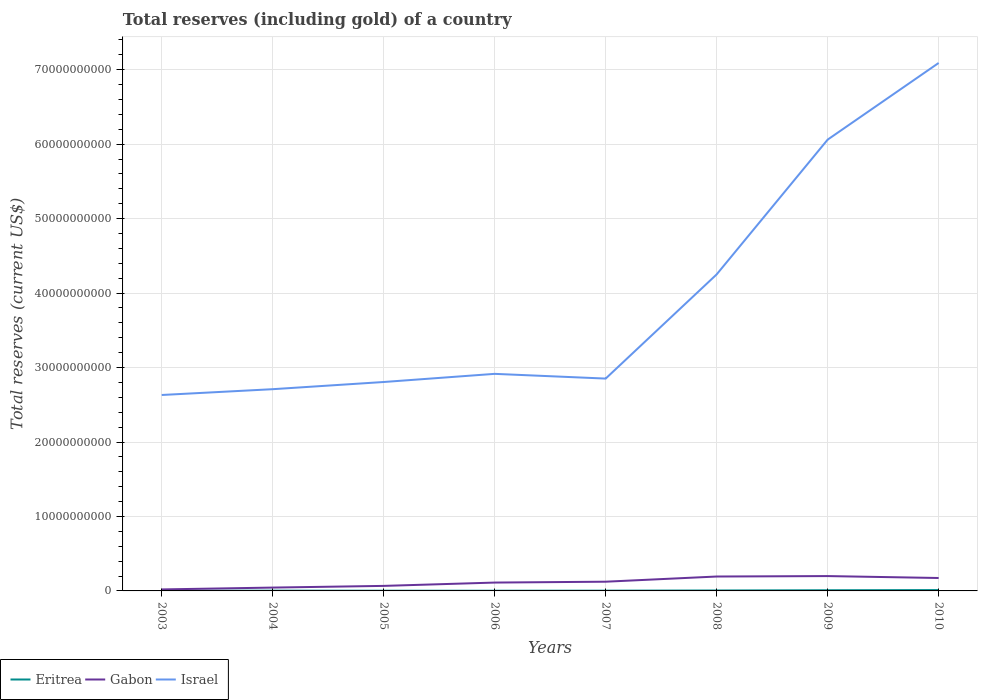How many different coloured lines are there?
Ensure brevity in your answer.  3. Is the number of lines equal to the number of legend labels?
Give a very brief answer. Yes. Across all years, what is the maximum total reserves (including gold) in Israel?
Give a very brief answer. 2.63e+1. In which year was the total reserves (including gold) in Eritrea maximum?
Offer a very short reply. 2003. What is the total total reserves (including gold) in Israel in the graph?
Your response must be concise. -3.15e+1. What is the difference between the highest and the second highest total reserves (including gold) in Israel?
Your answer should be very brief. 4.46e+1. What is the difference between the highest and the lowest total reserves (including gold) in Eritrea?
Your answer should be very brief. 3. Is the total reserves (including gold) in Gabon strictly greater than the total reserves (including gold) in Israel over the years?
Offer a terse response. Yes. How many years are there in the graph?
Your answer should be very brief. 8. What is the difference between two consecutive major ticks on the Y-axis?
Your answer should be compact. 1.00e+1. How many legend labels are there?
Offer a very short reply. 3. What is the title of the graph?
Provide a short and direct response. Total reserves (including gold) of a country. Does "Latvia" appear as one of the legend labels in the graph?
Your answer should be compact. No. What is the label or title of the X-axis?
Your answer should be compact. Years. What is the label or title of the Y-axis?
Make the answer very short. Total reserves (current US$). What is the Total reserves (current US$) of Eritrea in 2003?
Give a very brief answer. 2.47e+07. What is the Total reserves (current US$) of Gabon in 2003?
Your answer should be very brief. 2.02e+08. What is the Total reserves (current US$) of Israel in 2003?
Your response must be concise. 2.63e+1. What is the Total reserves (current US$) of Eritrea in 2004?
Make the answer very short. 3.47e+07. What is the Total reserves (current US$) in Gabon in 2004?
Make the answer very short. 4.49e+08. What is the Total reserves (current US$) of Israel in 2004?
Make the answer very short. 2.71e+1. What is the Total reserves (current US$) in Eritrea in 2005?
Ensure brevity in your answer.  2.79e+07. What is the Total reserves (current US$) in Gabon in 2005?
Make the answer very short. 6.75e+08. What is the Total reserves (current US$) of Israel in 2005?
Give a very brief answer. 2.81e+1. What is the Total reserves (current US$) in Eritrea in 2006?
Offer a terse response. 2.54e+07. What is the Total reserves (current US$) in Gabon in 2006?
Offer a terse response. 1.12e+09. What is the Total reserves (current US$) of Israel in 2006?
Ensure brevity in your answer.  2.92e+1. What is the Total reserves (current US$) of Eritrea in 2007?
Your response must be concise. 3.43e+07. What is the Total reserves (current US$) in Gabon in 2007?
Ensure brevity in your answer.  1.24e+09. What is the Total reserves (current US$) of Israel in 2007?
Keep it short and to the point. 2.85e+1. What is the Total reserves (current US$) of Eritrea in 2008?
Ensure brevity in your answer.  5.79e+07. What is the Total reserves (current US$) in Gabon in 2008?
Your answer should be very brief. 1.93e+09. What is the Total reserves (current US$) of Israel in 2008?
Keep it short and to the point. 4.25e+1. What is the Total reserves (current US$) in Eritrea in 2009?
Offer a very short reply. 9.00e+07. What is the Total reserves (current US$) of Gabon in 2009?
Make the answer very short. 1.99e+09. What is the Total reserves (current US$) in Israel in 2009?
Your answer should be compact. 6.06e+1. What is the Total reserves (current US$) in Eritrea in 2010?
Give a very brief answer. 1.14e+08. What is the Total reserves (current US$) in Gabon in 2010?
Provide a succinct answer. 1.74e+09. What is the Total reserves (current US$) in Israel in 2010?
Your answer should be compact. 7.09e+1. Across all years, what is the maximum Total reserves (current US$) of Eritrea?
Keep it short and to the point. 1.14e+08. Across all years, what is the maximum Total reserves (current US$) in Gabon?
Your answer should be compact. 1.99e+09. Across all years, what is the maximum Total reserves (current US$) of Israel?
Give a very brief answer. 7.09e+1. Across all years, what is the minimum Total reserves (current US$) of Eritrea?
Your answer should be very brief. 2.47e+07. Across all years, what is the minimum Total reserves (current US$) in Gabon?
Provide a succinct answer. 2.02e+08. Across all years, what is the minimum Total reserves (current US$) in Israel?
Provide a succinct answer. 2.63e+1. What is the total Total reserves (current US$) in Eritrea in the graph?
Ensure brevity in your answer.  4.09e+08. What is the total Total reserves (current US$) of Gabon in the graph?
Your response must be concise. 9.35e+09. What is the total Total reserves (current US$) of Israel in the graph?
Your answer should be compact. 3.13e+11. What is the difference between the Total reserves (current US$) in Eritrea in 2003 and that in 2004?
Ensure brevity in your answer.  -1.00e+07. What is the difference between the Total reserves (current US$) of Gabon in 2003 and that in 2004?
Give a very brief answer. -2.47e+08. What is the difference between the Total reserves (current US$) in Israel in 2003 and that in 2004?
Provide a succinct answer. -7.79e+08. What is the difference between the Total reserves (current US$) in Eritrea in 2003 and that in 2005?
Your response must be concise. -3.24e+06. What is the difference between the Total reserves (current US$) in Gabon in 2003 and that in 2005?
Your response must be concise. -4.73e+08. What is the difference between the Total reserves (current US$) in Israel in 2003 and that in 2005?
Ensure brevity in your answer.  -1.74e+09. What is the difference between the Total reserves (current US$) of Eritrea in 2003 and that in 2006?
Make the answer very short. -6.47e+05. What is the difference between the Total reserves (current US$) in Gabon in 2003 and that in 2006?
Give a very brief answer. -9.20e+08. What is the difference between the Total reserves (current US$) in Israel in 2003 and that in 2006?
Ensure brevity in your answer.  -2.84e+09. What is the difference between the Total reserves (current US$) of Eritrea in 2003 and that in 2007?
Give a very brief answer. -9.58e+06. What is the difference between the Total reserves (current US$) of Gabon in 2003 and that in 2007?
Your answer should be compact. -1.04e+09. What is the difference between the Total reserves (current US$) in Israel in 2003 and that in 2007?
Make the answer very short. -2.20e+09. What is the difference between the Total reserves (current US$) in Eritrea in 2003 and that in 2008?
Offer a terse response. -3.32e+07. What is the difference between the Total reserves (current US$) in Gabon in 2003 and that in 2008?
Your answer should be very brief. -1.73e+09. What is the difference between the Total reserves (current US$) in Israel in 2003 and that in 2008?
Ensure brevity in your answer.  -1.62e+1. What is the difference between the Total reserves (current US$) in Eritrea in 2003 and that in 2009?
Provide a short and direct response. -6.53e+07. What is the difference between the Total reserves (current US$) of Gabon in 2003 and that in 2009?
Give a very brief answer. -1.79e+09. What is the difference between the Total reserves (current US$) of Israel in 2003 and that in 2009?
Your response must be concise. -3.43e+1. What is the difference between the Total reserves (current US$) of Eritrea in 2003 and that in 2010?
Provide a succinct answer. -8.94e+07. What is the difference between the Total reserves (current US$) of Gabon in 2003 and that in 2010?
Your response must be concise. -1.53e+09. What is the difference between the Total reserves (current US$) in Israel in 2003 and that in 2010?
Your answer should be compact. -4.46e+1. What is the difference between the Total reserves (current US$) in Eritrea in 2004 and that in 2005?
Your response must be concise. 6.80e+06. What is the difference between the Total reserves (current US$) in Gabon in 2004 and that in 2005?
Make the answer very short. -2.26e+08. What is the difference between the Total reserves (current US$) of Israel in 2004 and that in 2005?
Make the answer very short. -9.65e+08. What is the difference between the Total reserves (current US$) of Eritrea in 2004 and that in 2006?
Keep it short and to the point. 9.39e+06. What is the difference between the Total reserves (current US$) in Gabon in 2004 and that in 2006?
Your response must be concise. -6.73e+08. What is the difference between the Total reserves (current US$) in Israel in 2004 and that in 2006?
Offer a terse response. -2.06e+09. What is the difference between the Total reserves (current US$) in Eritrea in 2004 and that in 2007?
Give a very brief answer. 4.62e+05. What is the difference between the Total reserves (current US$) in Gabon in 2004 and that in 2007?
Provide a succinct answer. -7.89e+08. What is the difference between the Total reserves (current US$) in Israel in 2004 and that in 2007?
Your answer should be very brief. -1.42e+09. What is the difference between the Total reserves (current US$) of Eritrea in 2004 and that in 2008?
Give a very brief answer. -2.32e+07. What is the difference between the Total reserves (current US$) in Gabon in 2004 and that in 2008?
Your answer should be compact. -1.49e+09. What is the difference between the Total reserves (current US$) of Israel in 2004 and that in 2008?
Offer a very short reply. -1.54e+1. What is the difference between the Total reserves (current US$) of Eritrea in 2004 and that in 2009?
Ensure brevity in your answer.  -5.53e+07. What is the difference between the Total reserves (current US$) in Gabon in 2004 and that in 2009?
Give a very brief answer. -1.54e+09. What is the difference between the Total reserves (current US$) of Israel in 2004 and that in 2009?
Provide a short and direct response. -3.35e+1. What is the difference between the Total reserves (current US$) of Eritrea in 2004 and that in 2010?
Your answer should be very brief. -7.94e+07. What is the difference between the Total reserves (current US$) in Gabon in 2004 and that in 2010?
Offer a terse response. -1.29e+09. What is the difference between the Total reserves (current US$) of Israel in 2004 and that in 2010?
Your answer should be very brief. -4.38e+1. What is the difference between the Total reserves (current US$) of Eritrea in 2005 and that in 2006?
Offer a terse response. 2.59e+06. What is the difference between the Total reserves (current US$) of Gabon in 2005 and that in 2006?
Make the answer very short. -4.46e+08. What is the difference between the Total reserves (current US$) in Israel in 2005 and that in 2006?
Keep it short and to the point. -1.09e+09. What is the difference between the Total reserves (current US$) of Eritrea in 2005 and that in 2007?
Your answer should be very brief. -6.34e+06. What is the difference between the Total reserves (current US$) of Gabon in 2005 and that in 2007?
Provide a succinct answer. -5.63e+08. What is the difference between the Total reserves (current US$) in Israel in 2005 and that in 2007?
Give a very brief answer. -4.59e+08. What is the difference between the Total reserves (current US$) in Eritrea in 2005 and that in 2008?
Make the answer very short. -3.00e+07. What is the difference between the Total reserves (current US$) in Gabon in 2005 and that in 2008?
Offer a very short reply. -1.26e+09. What is the difference between the Total reserves (current US$) in Israel in 2005 and that in 2008?
Give a very brief answer. -1.45e+1. What is the difference between the Total reserves (current US$) of Eritrea in 2005 and that in 2009?
Provide a succinct answer. -6.21e+07. What is the difference between the Total reserves (current US$) of Gabon in 2005 and that in 2009?
Offer a terse response. -1.32e+09. What is the difference between the Total reserves (current US$) of Israel in 2005 and that in 2009?
Keep it short and to the point. -3.26e+1. What is the difference between the Total reserves (current US$) of Eritrea in 2005 and that in 2010?
Provide a succinct answer. -8.62e+07. What is the difference between the Total reserves (current US$) in Gabon in 2005 and that in 2010?
Your answer should be very brief. -1.06e+09. What is the difference between the Total reserves (current US$) of Israel in 2005 and that in 2010?
Provide a succinct answer. -4.28e+1. What is the difference between the Total reserves (current US$) of Eritrea in 2006 and that in 2007?
Provide a short and direct response. -8.93e+06. What is the difference between the Total reserves (current US$) in Gabon in 2006 and that in 2007?
Offer a very short reply. -1.16e+08. What is the difference between the Total reserves (current US$) in Israel in 2006 and that in 2007?
Your answer should be compact. 6.35e+08. What is the difference between the Total reserves (current US$) of Eritrea in 2006 and that in 2008?
Offer a terse response. -3.25e+07. What is the difference between the Total reserves (current US$) of Gabon in 2006 and that in 2008?
Your answer should be compact. -8.13e+08. What is the difference between the Total reserves (current US$) of Israel in 2006 and that in 2008?
Offer a very short reply. -1.34e+1. What is the difference between the Total reserves (current US$) in Eritrea in 2006 and that in 2009?
Ensure brevity in your answer.  -6.47e+07. What is the difference between the Total reserves (current US$) of Gabon in 2006 and that in 2009?
Your answer should be compact. -8.72e+08. What is the difference between the Total reserves (current US$) in Israel in 2006 and that in 2009?
Your answer should be very brief. -3.15e+1. What is the difference between the Total reserves (current US$) in Eritrea in 2006 and that in 2010?
Your answer should be very brief. -8.88e+07. What is the difference between the Total reserves (current US$) in Gabon in 2006 and that in 2010?
Provide a short and direct response. -6.14e+08. What is the difference between the Total reserves (current US$) of Israel in 2006 and that in 2010?
Give a very brief answer. -4.18e+1. What is the difference between the Total reserves (current US$) in Eritrea in 2007 and that in 2008?
Give a very brief answer. -2.36e+07. What is the difference between the Total reserves (current US$) of Gabon in 2007 and that in 2008?
Offer a very short reply. -6.97e+08. What is the difference between the Total reserves (current US$) in Israel in 2007 and that in 2008?
Offer a very short reply. -1.40e+1. What is the difference between the Total reserves (current US$) of Eritrea in 2007 and that in 2009?
Offer a terse response. -5.57e+07. What is the difference between the Total reserves (current US$) in Gabon in 2007 and that in 2009?
Your response must be concise. -7.55e+08. What is the difference between the Total reserves (current US$) of Israel in 2007 and that in 2009?
Your answer should be compact. -3.21e+1. What is the difference between the Total reserves (current US$) of Eritrea in 2007 and that in 2010?
Keep it short and to the point. -7.99e+07. What is the difference between the Total reserves (current US$) in Gabon in 2007 and that in 2010?
Your answer should be very brief. -4.98e+08. What is the difference between the Total reserves (current US$) of Israel in 2007 and that in 2010?
Your response must be concise. -4.24e+1. What is the difference between the Total reserves (current US$) of Eritrea in 2008 and that in 2009?
Ensure brevity in your answer.  -3.21e+07. What is the difference between the Total reserves (current US$) in Gabon in 2008 and that in 2009?
Keep it short and to the point. -5.86e+07. What is the difference between the Total reserves (current US$) of Israel in 2008 and that in 2009?
Make the answer very short. -1.81e+1. What is the difference between the Total reserves (current US$) in Eritrea in 2008 and that in 2010?
Offer a terse response. -5.63e+07. What is the difference between the Total reserves (current US$) in Gabon in 2008 and that in 2010?
Your answer should be very brief. 1.99e+08. What is the difference between the Total reserves (current US$) in Israel in 2008 and that in 2010?
Offer a very short reply. -2.84e+1. What is the difference between the Total reserves (current US$) in Eritrea in 2009 and that in 2010?
Provide a succinct answer. -2.41e+07. What is the difference between the Total reserves (current US$) in Gabon in 2009 and that in 2010?
Provide a short and direct response. 2.57e+08. What is the difference between the Total reserves (current US$) of Israel in 2009 and that in 2010?
Offer a very short reply. -1.03e+1. What is the difference between the Total reserves (current US$) of Eritrea in 2003 and the Total reserves (current US$) of Gabon in 2004?
Give a very brief answer. -4.24e+08. What is the difference between the Total reserves (current US$) in Eritrea in 2003 and the Total reserves (current US$) in Israel in 2004?
Offer a very short reply. -2.71e+1. What is the difference between the Total reserves (current US$) in Gabon in 2003 and the Total reserves (current US$) in Israel in 2004?
Give a very brief answer. -2.69e+1. What is the difference between the Total reserves (current US$) in Eritrea in 2003 and the Total reserves (current US$) in Gabon in 2005?
Offer a very short reply. -6.50e+08. What is the difference between the Total reserves (current US$) of Eritrea in 2003 and the Total reserves (current US$) of Israel in 2005?
Make the answer very short. -2.80e+1. What is the difference between the Total reserves (current US$) in Gabon in 2003 and the Total reserves (current US$) in Israel in 2005?
Offer a terse response. -2.79e+1. What is the difference between the Total reserves (current US$) of Eritrea in 2003 and the Total reserves (current US$) of Gabon in 2006?
Provide a short and direct response. -1.10e+09. What is the difference between the Total reserves (current US$) in Eritrea in 2003 and the Total reserves (current US$) in Israel in 2006?
Give a very brief answer. -2.91e+1. What is the difference between the Total reserves (current US$) in Gabon in 2003 and the Total reserves (current US$) in Israel in 2006?
Keep it short and to the point. -2.90e+1. What is the difference between the Total reserves (current US$) in Eritrea in 2003 and the Total reserves (current US$) in Gabon in 2007?
Your answer should be very brief. -1.21e+09. What is the difference between the Total reserves (current US$) of Eritrea in 2003 and the Total reserves (current US$) of Israel in 2007?
Your answer should be compact. -2.85e+1. What is the difference between the Total reserves (current US$) in Gabon in 2003 and the Total reserves (current US$) in Israel in 2007?
Provide a short and direct response. -2.83e+1. What is the difference between the Total reserves (current US$) in Eritrea in 2003 and the Total reserves (current US$) in Gabon in 2008?
Offer a terse response. -1.91e+09. What is the difference between the Total reserves (current US$) in Eritrea in 2003 and the Total reserves (current US$) in Israel in 2008?
Give a very brief answer. -4.25e+1. What is the difference between the Total reserves (current US$) in Gabon in 2003 and the Total reserves (current US$) in Israel in 2008?
Your response must be concise. -4.23e+1. What is the difference between the Total reserves (current US$) in Eritrea in 2003 and the Total reserves (current US$) in Gabon in 2009?
Provide a short and direct response. -1.97e+09. What is the difference between the Total reserves (current US$) of Eritrea in 2003 and the Total reserves (current US$) of Israel in 2009?
Provide a succinct answer. -6.06e+1. What is the difference between the Total reserves (current US$) in Gabon in 2003 and the Total reserves (current US$) in Israel in 2009?
Offer a terse response. -6.04e+1. What is the difference between the Total reserves (current US$) of Eritrea in 2003 and the Total reserves (current US$) of Gabon in 2010?
Provide a succinct answer. -1.71e+09. What is the difference between the Total reserves (current US$) in Eritrea in 2003 and the Total reserves (current US$) in Israel in 2010?
Provide a succinct answer. -7.09e+1. What is the difference between the Total reserves (current US$) of Gabon in 2003 and the Total reserves (current US$) of Israel in 2010?
Provide a short and direct response. -7.07e+1. What is the difference between the Total reserves (current US$) in Eritrea in 2004 and the Total reserves (current US$) in Gabon in 2005?
Your answer should be compact. -6.40e+08. What is the difference between the Total reserves (current US$) of Eritrea in 2004 and the Total reserves (current US$) of Israel in 2005?
Provide a short and direct response. -2.80e+1. What is the difference between the Total reserves (current US$) in Gabon in 2004 and the Total reserves (current US$) in Israel in 2005?
Make the answer very short. -2.76e+1. What is the difference between the Total reserves (current US$) in Eritrea in 2004 and the Total reserves (current US$) in Gabon in 2006?
Offer a very short reply. -1.09e+09. What is the difference between the Total reserves (current US$) in Eritrea in 2004 and the Total reserves (current US$) in Israel in 2006?
Keep it short and to the point. -2.91e+1. What is the difference between the Total reserves (current US$) in Gabon in 2004 and the Total reserves (current US$) in Israel in 2006?
Provide a short and direct response. -2.87e+1. What is the difference between the Total reserves (current US$) in Eritrea in 2004 and the Total reserves (current US$) in Gabon in 2007?
Offer a very short reply. -1.20e+09. What is the difference between the Total reserves (current US$) of Eritrea in 2004 and the Total reserves (current US$) of Israel in 2007?
Offer a terse response. -2.85e+1. What is the difference between the Total reserves (current US$) of Gabon in 2004 and the Total reserves (current US$) of Israel in 2007?
Give a very brief answer. -2.81e+1. What is the difference between the Total reserves (current US$) of Eritrea in 2004 and the Total reserves (current US$) of Gabon in 2008?
Give a very brief answer. -1.90e+09. What is the difference between the Total reserves (current US$) of Eritrea in 2004 and the Total reserves (current US$) of Israel in 2008?
Keep it short and to the point. -4.25e+1. What is the difference between the Total reserves (current US$) of Gabon in 2004 and the Total reserves (current US$) of Israel in 2008?
Offer a terse response. -4.21e+1. What is the difference between the Total reserves (current US$) of Eritrea in 2004 and the Total reserves (current US$) of Gabon in 2009?
Your answer should be compact. -1.96e+09. What is the difference between the Total reserves (current US$) in Eritrea in 2004 and the Total reserves (current US$) in Israel in 2009?
Keep it short and to the point. -6.06e+1. What is the difference between the Total reserves (current US$) of Gabon in 2004 and the Total reserves (current US$) of Israel in 2009?
Give a very brief answer. -6.02e+1. What is the difference between the Total reserves (current US$) of Eritrea in 2004 and the Total reserves (current US$) of Gabon in 2010?
Your answer should be compact. -1.70e+09. What is the difference between the Total reserves (current US$) in Eritrea in 2004 and the Total reserves (current US$) in Israel in 2010?
Provide a short and direct response. -7.09e+1. What is the difference between the Total reserves (current US$) of Gabon in 2004 and the Total reserves (current US$) of Israel in 2010?
Provide a succinct answer. -7.05e+1. What is the difference between the Total reserves (current US$) in Eritrea in 2005 and the Total reserves (current US$) in Gabon in 2006?
Provide a succinct answer. -1.09e+09. What is the difference between the Total reserves (current US$) of Eritrea in 2005 and the Total reserves (current US$) of Israel in 2006?
Your answer should be very brief. -2.91e+1. What is the difference between the Total reserves (current US$) of Gabon in 2005 and the Total reserves (current US$) of Israel in 2006?
Offer a terse response. -2.85e+1. What is the difference between the Total reserves (current US$) in Eritrea in 2005 and the Total reserves (current US$) in Gabon in 2007?
Your answer should be compact. -1.21e+09. What is the difference between the Total reserves (current US$) in Eritrea in 2005 and the Total reserves (current US$) in Israel in 2007?
Provide a succinct answer. -2.85e+1. What is the difference between the Total reserves (current US$) of Gabon in 2005 and the Total reserves (current US$) of Israel in 2007?
Give a very brief answer. -2.78e+1. What is the difference between the Total reserves (current US$) of Eritrea in 2005 and the Total reserves (current US$) of Gabon in 2008?
Offer a very short reply. -1.91e+09. What is the difference between the Total reserves (current US$) of Eritrea in 2005 and the Total reserves (current US$) of Israel in 2008?
Ensure brevity in your answer.  -4.25e+1. What is the difference between the Total reserves (current US$) in Gabon in 2005 and the Total reserves (current US$) in Israel in 2008?
Give a very brief answer. -4.18e+1. What is the difference between the Total reserves (current US$) in Eritrea in 2005 and the Total reserves (current US$) in Gabon in 2009?
Give a very brief answer. -1.97e+09. What is the difference between the Total reserves (current US$) of Eritrea in 2005 and the Total reserves (current US$) of Israel in 2009?
Keep it short and to the point. -6.06e+1. What is the difference between the Total reserves (current US$) in Gabon in 2005 and the Total reserves (current US$) in Israel in 2009?
Your answer should be compact. -5.99e+1. What is the difference between the Total reserves (current US$) in Eritrea in 2005 and the Total reserves (current US$) in Gabon in 2010?
Offer a terse response. -1.71e+09. What is the difference between the Total reserves (current US$) of Eritrea in 2005 and the Total reserves (current US$) of Israel in 2010?
Provide a succinct answer. -7.09e+1. What is the difference between the Total reserves (current US$) in Gabon in 2005 and the Total reserves (current US$) in Israel in 2010?
Your answer should be compact. -7.02e+1. What is the difference between the Total reserves (current US$) in Eritrea in 2006 and the Total reserves (current US$) in Gabon in 2007?
Provide a succinct answer. -1.21e+09. What is the difference between the Total reserves (current US$) in Eritrea in 2006 and the Total reserves (current US$) in Israel in 2007?
Offer a terse response. -2.85e+1. What is the difference between the Total reserves (current US$) of Gabon in 2006 and the Total reserves (current US$) of Israel in 2007?
Provide a succinct answer. -2.74e+1. What is the difference between the Total reserves (current US$) in Eritrea in 2006 and the Total reserves (current US$) in Gabon in 2008?
Your answer should be compact. -1.91e+09. What is the difference between the Total reserves (current US$) of Eritrea in 2006 and the Total reserves (current US$) of Israel in 2008?
Offer a terse response. -4.25e+1. What is the difference between the Total reserves (current US$) of Gabon in 2006 and the Total reserves (current US$) of Israel in 2008?
Offer a very short reply. -4.14e+1. What is the difference between the Total reserves (current US$) in Eritrea in 2006 and the Total reserves (current US$) in Gabon in 2009?
Your answer should be very brief. -1.97e+09. What is the difference between the Total reserves (current US$) of Eritrea in 2006 and the Total reserves (current US$) of Israel in 2009?
Your answer should be very brief. -6.06e+1. What is the difference between the Total reserves (current US$) in Gabon in 2006 and the Total reserves (current US$) in Israel in 2009?
Your response must be concise. -5.95e+1. What is the difference between the Total reserves (current US$) of Eritrea in 2006 and the Total reserves (current US$) of Gabon in 2010?
Your answer should be compact. -1.71e+09. What is the difference between the Total reserves (current US$) in Eritrea in 2006 and the Total reserves (current US$) in Israel in 2010?
Your answer should be compact. -7.09e+1. What is the difference between the Total reserves (current US$) of Gabon in 2006 and the Total reserves (current US$) of Israel in 2010?
Provide a short and direct response. -6.98e+1. What is the difference between the Total reserves (current US$) of Eritrea in 2007 and the Total reserves (current US$) of Gabon in 2008?
Give a very brief answer. -1.90e+09. What is the difference between the Total reserves (current US$) of Eritrea in 2007 and the Total reserves (current US$) of Israel in 2008?
Keep it short and to the point. -4.25e+1. What is the difference between the Total reserves (current US$) of Gabon in 2007 and the Total reserves (current US$) of Israel in 2008?
Provide a succinct answer. -4.13e+1. What is the difference between the Total reserves (current US$) in Eritrea in 2007 and the Total reserves (current US$) in Gabon in 2009?
Make the answer very short. -1.96e+09. What is the difference between the Total reserves (current US$) of Eritrea in 2007 and the Total reserves (current US$) of Israel in 2009?
Your answer should be very brief. -6.06e+1. What is the difference between the Total reserves (current US$) of Gabon in 2007 and the Total reserves (current US$) of Israel in 2009?
Your response must be concise. -5.94e+1. What is the difference between the Total reserves (current US$) in Eritrea in 2007 and the Total reserves (current US$) in Gabon in 2010?
Make the answer very short. -1.70e+09. What is the difference between the Total reserves (current US$) in Eritrea in 2007 and the Total reserves (current US$) in Israel in 2010?
Your answer should be compact. -7.09e+1. What is the difference between the Total reserves (current US$) in Gabon in 2007 and the Total reserves (current US$) in Israel in 2010?
Give a very brief answer. -6.97e+1. What is the difference between the Total reserves (current US$) in Eritrea in 2008 and the Total reserves (current US$) in Gabon in 2009?
Ensure brevity in your answer.  -1.94e+09. What is the difference between the Total reserves (current US$) of Eritrea in 2008 and the Total reserves (current US$) of Israel in 2009?
Keep it short and to the point. -6.06e+1. What is the difference between the Total reserves (current US$) in Gabon in 2008 and the Total reserves (current US$) in Israel in 2009?
Your response must be concise. -5.87e+1. What is the difference between the Total reserves (current US$) of Eritrea in 2008 and the Total reserves (current US$) of Gabon in 2010?
Offer a terse response. -1.68e+09. What is the difference between the Total reserves (current US$) of Eritrea in 2008 and the Total reserves (current US$) of Israel in 2010?
Provide a succinct answer. -7.08e+1. What is the difference between the Total reserves (current US$) of Gabon in 2008 and the Total reserves (current US$) of Israel in 2010?
Offer a terse response. -6.90e+1. What is the difference between the Total reserves (current US$) of Eritrea in 2009 and the Total reserves (current US$) of Gabon in 2010?
Provide a short and direct response. -1.65e+09. What is the difference between the Total reserves (current US$) in Eritrea in 2009 and the Total reserves (current US$) in Israel in 2010?
Ensure brevity in your answer.  -7.08e+1. What is the difference between the Total reserves (current US$) of Gabon in 2009 and the Total reserves (current US$) of Israel in 2010?
Your response must be concise. -6.89e+1. What is the average Total reserves (current US$) in Eritrea per year?
Make the answer very short. 5.11e+07. What is the average Total reserves (current US$) of Gabon per year?
Your answer should be compact. 1.17e+09. What is the average Total reserves (current US$) of Israel per year?
Your answer should be very brief. 3.91e+1. In the year 2003, what is the difference between the Total reserves (current US$) in Eritrea and Total reserves (current US$) in Gabon?
Offer a very short reply. -1.77e+08. In the year 2003, what is the difference between the Total reserves (current US$) of Eritrea and Total reserves (current US$) of Israel?
Provide a short and direct response. -2.63e+1. In the year 2003, what is the difference between the Total reserves (current US$) in Gabon and Total reserves (current US$) in Israel?
Provide a succinct answer. -2.61e+1. In the year 2004, what is the difference between the Total reserves (current US$) in Eritrea and Total reserves (current US$) in Gabon?
Your answer should be compact. -4.14e+08. In the year 2004, what is the difference between the Total reserves (current US$) in Eritrea and Total reserves (current US$) in Israel?
Provide a succinct answer. -2.71e+1. In the year 2004, what is the difference between the Total reserves (current US$) of Gabon and Total reserves (current US$) of Israel?
Offer a terse response. -2.66e+1. In the year 2005, what is the difference between the Total reserves (current US$) in Eritrea and Total reserves (current US$) in Gabon?
Offer a terse response. -6.47e+08. In the year 2005, what is the difference between the Total reserves (current US$) of Eritrea and Total reserves (current US$) of Israel?
Offer a very short reply. -2.80e+1. In the year 2005, what is the difference between the Total reserves (current US$) of Gabon and Total reserves (current US$) of Israel?
Offer a very short reply. -2.74e+1. In the year 2006, what is the difference between the Total reserves (current US$) of Eritrea and Total reserves (current US$) of Gabon?
Your answer should be compact. -1.10e+09. In the year 2006, what is the difference between the Total reserves (current US$) of Eritrea and Total reserves (current US$) of Israel?
Ensure brevity in your answer.  -2.91e+1. In the year 2006, what is the difference between the Total reserves (current US$) in Gabon and Total reserves (current US$) in Israel?
Your response must be concise. -2.80e+1. In the year 2007, what is the difference between the Total reserves (current US$) in Eritrea and Total reserves (current US$) in Gabon?
Ensure brevity in your answer.  -1.20e+09. In the year 2007, what is the difference between the Total reserves (current US$) in Eritrea and Total reserves (current US$) in Israel?
Provide a short and direct response. -2.85e+1. In the year 2007, what is the difference between the Total reserves (current US$) in Gabon and Total reserves (current US$) in Israel?
Your response must be concise. -2.73e+1. In the year 2008, what is the difference between the Total reserves (current US$) of Eritrea and Total reserves (current US$) of Gabon?
Your response must be concise. -1.88e+09. In the year 2008, what is the difference between the Total reserves (current US$) of Eritrea and Total reserves (current US$) of Israel?
Provide a succinct answer. -4.25e+1. In the year 2008, what is the difference between the Total reserves (current US$) in Gabon and Total reserves (current US$) in Israel?
Offer a very short reply. -4.06e+1. In the year 2009, what is the difference between the Total reserves (current US$) in Eritrea and Total reserves (current US$) in Gabon?
Offer a terse response. -1.90e+09. In the year 2009, what is the difference between the Total reserves (current US$) in Eritrea and Total reserves (current US$) in Israel?
Your answer should be compact. -6.05e+1. In the year 2009, what is the difference between the Total reserves (current US$) in Gabon and Total reserves (current US$) in Israel?
Provide a short and direct response. -5.86e+1. In the year 2010, what is the difference between the Total reserves (current US$) of Eritrea and Total reserves (current US$) of Gabon?
Your answer should be compact. -1.62e+09. In the year 2010, what is the difference between the Total reserves (current US$) of Eritrea and Total reserves (current US$) of Israel?
Your answer should be very brief. -7.08e+1. In the year 2010, what is the difference between the Total reserves (current US$) of Gabon and Total reserves (current US$) of Israel?
Your answer should be very brief. -6.92e+1. What is the ratio of the Total reserves (current US$) in Eritrea in 2003 to that in 2004?
Provide a succinct answer. 0.71. What is the ratio of the Total reserves (current US$) of Gabon in 2003 to that in 2004?
Keep it short and to the point. 0.45. What is the ratio of the Total reserves (current US$) in Israel in 2003 to that in 2004?
Provide a short and direct response. 0.97. What is the ratio of the Total reserves (current US$) in Eritrea in 2003 to that in 2005?
Offer a terse response. 0.88. What is the ratio of the Total reserves (current US$) of Gabon in 2003 to that in 2005?
Your answer should be very brief. 0.3. What is the ratio of the Total reserves (current US$) of Israel in 2003 to that in 2005?
Offer a terse response. 0.94. What is the ratio of the Total reserves (current US$) in Eritrea in 2003 to that in 2006?
Keep it short and to the point. 0.97. What is the ratio of the Total reserves (current US$) in Gabon in 2003 to that in 2006?
Offer a very short reply. 0.18. What is the ratio of the Total reserves (current US$) in Israel in 2003 to that in 2006?
Ensure brevity in your answer.  0.9. What is the ratio of the Total reserves (current US$) in Eritrea in 2003 to that in 2007?
Ensure brevity in your answer.  0.72. What is the ratio of the Total reserves (current US$) in Gabon in 2003 to that in 2007?
Give a very brief answer. 0.16. What is the ratio of the Total reserves (current US$) of Israel in 2003 to that in 2007?
Ensure brevity in your answer.  0.92. What is the ratio of the Total reserves (current US$) of Eritrea in 2003 to that in 2008?
Make the answer very short. 0.43. What is the ratio of the Total reserves (current US$) of Gabon in 2003 to that in 2008?
Your response must be concise. 0.1. What is the ratio of the Total reserves (current US$) in Israel in 2003 to that in 2008?
Your response must be concise. 0.62. What is the ratio of the Total reserves (current US$) in Eritrea in 2003 to that in 2009?
Your answer should be compact. 0.27. What is the ratio of the Total reserves (current US$) in Gabon in 2003 to that in 2009?
Offer a terse response. 0.1. What is the ratio of the Total reserves (current US$) of Israel in 2003 to that in 2009?
Ensure brevity in your answer.  0.43. What is the ratio of the Total reserves (current US$) in Eritrea in 2003 to that in 2010?
Make the answer very short. 0.22. What is the ratio of the Total reserves (current US$) of Gabon in 2003 to that in 2010?
Provide a short and direct response. 0.12. What is the ratio of the Total reserves (current US$) in Israel in 2003 to that in 2010?
Keep it short and to the point. 0.37. What is the ratio of the Total reserves (current US$) of Eritrea in 2004 to that in 2005?
Your answer should be very brief. 1.24. What is the ratio of the Total reserves (current US$) in Gabon in 2004 to that in 2005?
Give a very brief answer. 0.67. What is the ratio of the Total reserves (current US$) in Israel in 2004 to that in 2005?
Ensure brevity in your answer.  0.97. What is the ratio of the Total reserves (current US$) in Eritrea in 2004 to that in 2006?
Make the answer very short. 1.37. What is the ratio of the Total reserves (current US$) in Gabon in 2004 to that in 2006?
Your answer should be very brief. 0.4. What is the ratio of the Total reserves (current US$) in Israel in 2004 to that in 2006?
Offer a very short reply. 0.93. What is the ratio of the Total reserves (current US$) of Eritrea in 2004 to that in 2007?
Offer a very short reply. 1.01. What is the ratio of the Total reserves (current US$) in Gabon in 2004 to that in 2007?
Your answer should be very brief. 0.36. What is the ratio of the Total reserves (current US$) in Israel in 2004 to that in 2007?
Provide a succinct answer. 0.95. What is the ratio of the Total reserves (current US$) of Eritrea in 2004 to that in 2008?
Provide a short and direct response. 0.6. What is the ratio of the Total reserves (current US$) of Gabon in 2004 to that in 2008?
Your answer should be compact. 0.23. What is the ratio of the Total reserves (current US$) of Israel in 2004 to that in 2008?
Offer a terse response. 0.64. What is the ratio of the Total reserves (current US$) of Eritrea in 2004 to that in 2009?
Your response must be concise. 0.39. What is the ratio of the Total reserves (current US$) of Gabon in 2004 to that in 2009?
Make the answer very short. 0.23. What is the ratio of the Total reserves (current US$) in Israel in 2004 to that in 2009?
Keep it short and to the point. 0.45. What is the ratio of the Total reserves (current US$) in Eritrea in 2004 to that in 2010?
Offer a very short reply. 0.3. What is the ratio of the Total reserves (current US$) in Gabon in 2004 to that in 2010?
Provide a short and direct response. 0.26. What is the ratio of the Total reserves (current US$) of Israel in 2004 to that in 2010?
Your answer should be compact. 0.38. What is the ratio of the Total reserves (current US$) in Eritrea in 2005 to that in 2006?
Keep it short and to the point. 1.1. What is the ratio of the Total reserves (current US$) of Gabon in 2005 to that in 2006?
Offer a terse response. 0.6. What is the ratio of the Total reserves (current US$) in Israel in 2005 to that in 2006?
Your answer should be very brief. 0.96. What is the ratio of the Total reserves (current US$) of Eritrea in 2005 to that in 2007?
Provide a succinct answer. 0.82. What is the ratio of the Total reserves (current US$) in Gabon in 2005 to that in 2007?
Provide a succinct answer. 0.55. What is the ratio of the Total reserves (current US$) of Israel in 2005 to that in 2007?
Keep it short and to the point. 0.98. What is the ratio of the Total reserves (current US$) in Eritrea in 2005 to that in 2008?
Ensure brevity in your answer.  0.48. What is the ratio of the Total reserves (current US$) of Gabon in 2005 to that in 2008?
Give a very brief answer. 0.35. What is the ratio of the Total reserves (current US$) of Israel in 2005 to that in 2008?
Ensure brevity in your answer.  0.66. What is the ratio of the Total reserves (current US$) in Eritrea in 2005 to that in 2009?
Provide a succinct answer. 0.31. What is the ratio of the Total reserves (current US$) in Gabon in 2005 to that in 2009?
Make the answer very short. 0.34. What is the ratio of the Total reserves (current US$) in Israel in 2005 to that in 2009?
Keep it short and to the point. 0.46. What is the ratio of the Total reserves (current US$) of Eritrea in 2005 to that in 2010?
Your answer should be compact. 0.24. What is the ratio of the Total reserves (current US$) of Gabon in 2005 to that in 2010?
Provide a short and direct response. 0.39. What is the ratio of the Total reserves (current US$) of Israel in 2005 to that in 2010?
Ensure brevity in your answer.  0.4. What is the ratio of the Total reserves (current US$) in Eritrea in 2006 to that in 2007?
Your answer should be very brief. 0.74. What is the ratio of the Total reserves (current US$) in Gabon in 2006 to that in 2007?
Your response must be concise. 0.91. What is the ratio of the Total reserves (current US$) of Israel in 2006 to that in 2007?
Keep it short and to the point. 1.02. What is the ratio of the Total reserves (current US$) in Eritrea in 2006 to that in 2008?
Provide a short and direct response. 0.44. What is the ratio of the Total reserves (current US$) of Gabon in 2006 to that in 2008?
Your answer should be very brief. 0.58. What is the ratio of the Total reserves (current US$) of Israel in 2006 to that in 2008?
Your response must be concise. 0.69. What is the ratio of the Total reserves (current US$) of Eritrea in 2006 to that in 2009?
Make the answer very short. 0.28. What is the ratio of the Total reserves (current US$) in Gabon in 2006 to that in 2009?
Keep it short and to the point. 0.56. What is the ratio of the Total reserves (current US$) of Israel in 2006 to that in 2009?
Keep it short and to the point. 0.48. What is the ratio of the Total reserves (current US$) of Eritrea in 2006 to that in 2010?
Ensure brevity in your answer.  0.22. What is the ratio of the Total reserves (current US$) of Gabon in 2006 to that in 2010?
Give a very brief answer. 0.65. What is the ratio of the Total reserves (current US$) of Israel in 2006 to that in 2010?
Provide a succinct answer. 0.41. What is the ratio of the Total reserves (current US$) in Eritrea in 2007 to that in 2008?
Make the answer very short. 0.59. What is the ratio of the Total reserves (current US$) of Gabon in 2007 to that in 2008?
Make the answer very short. 0.64. What is the ratio of the Total reserves (current US$) in Israel in 2007 to that in 2008?
Your answer should be very brief. 0.67. What is the ratio of the Total reserves (current US$) of Eritrea in 2007 to that in 2009?
Offer a very short reply. 0.38. What is the ratio of the Total reserves (current US$) in Gabon in 2007 to that in 2009?
Keep it short and to the point. 0.62. What is the ratio of the Total reserves (current US$) of Israel in 2007 to that in 2009?
Your answer should be compact. 0.47. What is the ratio of the Total reserves (current US$) of Eritrea in 2007 to that in 2010?
Offer a very short reply. 0.3. What is the ratio of the Total reserves (current US$) of Gabon in 2007 to that in 2010?
Provide a succinct answer. 0.71. What is the ratio of the Total reserves (current US$) of Israel in 2007 to that in 2010?
Your answer should be very brief. 0.4. What is the ratio of the Total reserves (current US$) in Eritrea in 2008 to that in 2009?
Provide a short and direct response. 0.64. What is the ratio of the Total reserves (current US$) of Gabon in 2008 to that in 2009?
Make the answer very short. 0.97. What is the ratio of the Total reserves (current US$) in Israel in 2008 to that in 2009?
Your answer should be compact. 0.7. What is the ratio of the Total reserves (current US$) in Eritrea in 2008 to that in 2010?
Ensure brevity in your answer.  0.51. What is the ratio of the Total reserves (current US$) in Gabon in 2008 to that in 2010?
Ensure brevity in your answer.  1.11. What is the ratio of the Total reserves (current US$) of Israel in 2008 to that in 2010?
Keep it short and to the point. 0.6. What is the ratio of the Total reserves (current US$) of Eritrea in 2009 to that in 2010?
Your answer should be very brief. 0.79. What is the ratio of the Total reserves (current US$) of Gabon in 2009 to that in 2010?
Your response must be concise. 1.15. What is the ratio of the Total reserves (current US$) of Israel in 2009 to that in 2010?
Offer a terse response. 0.85. What is the difference between the highest and the second highest Total reserves (current US$) of Eritrea?
Make the answer very short. 2.41e+07. What is the difference between the highest and the second highest Total reserves (current US$) in Gabon?
Make the answer very short. 5.86e+07. What is the difference between the highest and the second highest Total reserves (current US$) in Israel?
Make the answer very short. 1.03e+1. What is the difference between the highest and the lowest Total reserves (current US$) of Eritrea?
Give a very brief answer. 8.94e+07. What is the difference between the highest and the lowest Total reserves (current US$) in Gabon?
Provide a succinct answer. 1.79e+09. What is the difference between the highest and the lowest Total reserves (current US$) of Israel?
Your answer should be very brief. 4.46e+1. 